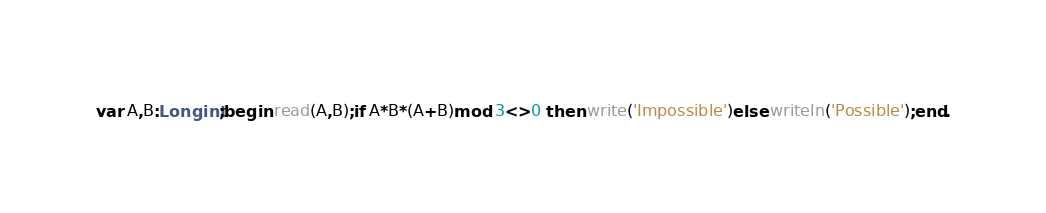<code> <loc_0><loc_0><loc_500><loc_500><_Pascal_>var A,B:Longint;begin read(A,B);if A*B*(A+B)mod 3<>0 then write('Impossible')else writeln('Possible');end.</code> 